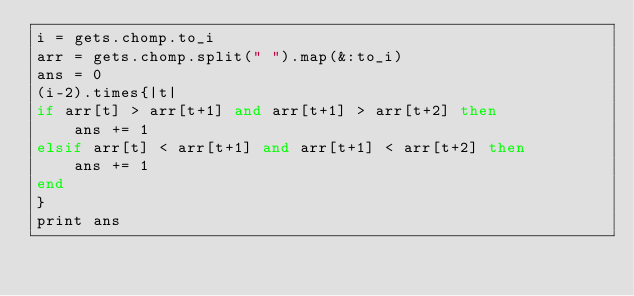<code> <loc_0><loc_0><loc_500><loc_500><_Ruby_>i = gets.chomp.to_i
arr = gets.chomp.split(" ").map(&:to_i)
ans = 0
(i-2).times{|t|
if arr[t] > arr[t+1] and arr[t+1] > arr[t+2] then
    ans += 1
elsif arr[t] < arr[t+1] and arr[t+1] < arr[t+2] then
    ans += 1
end
}
print ans</code> 